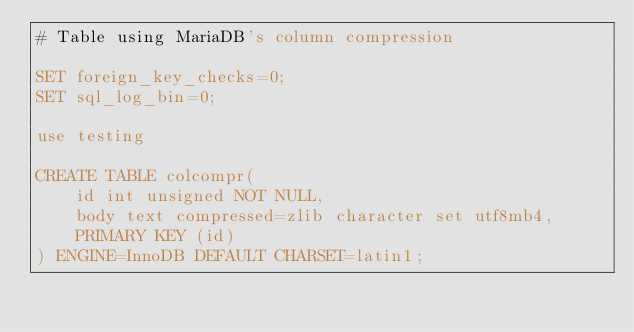Convert code to text. <code><loc_0><loc_0><loc_500><loc_500><_SQL_># Table using MariaDB's column compression

SET foreign_key_checks=0;
SET sql_log_bin=0;

use testing

CREATE TABLE colcompr(
	id int unsigned NOT NULL,
	body text compressed=zlib character set utf8mb4,
	PRIMARY KEY (id)
) ENGINE=InnoDB DEFAULT CHARSET=latin1;
</code> 